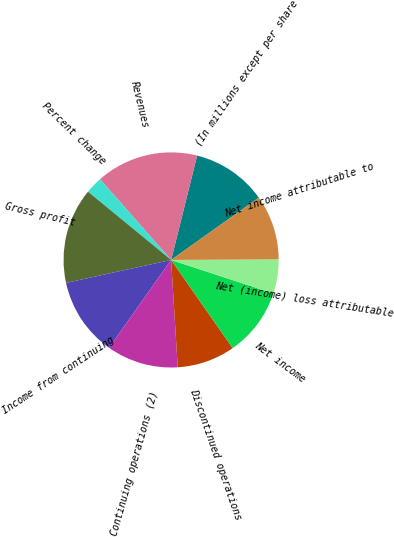Convert chart. <chart><loc_0><loc_0><loc_500><loc_500><pie_chart><fcel>(In millions except per share<fcel>Revenues<fcel>Percent change<fcel>Gross profit<fcel>Income from continuing<fcel>Continuing operations (2)<fcel>Discontinued operations<fcel>Net income<fcel>Net (income) loss attributable<fcel>Net income attributable to<nl><fcel>11.28%<fcel>15.38%<fcel>2.56%<fcel>14.36%<fcel>11.79%<fcel>10.77%<fcel>8.72%<fcel>10.26%<fcel>5.13%<fcel>9.74%<nl></chart> 